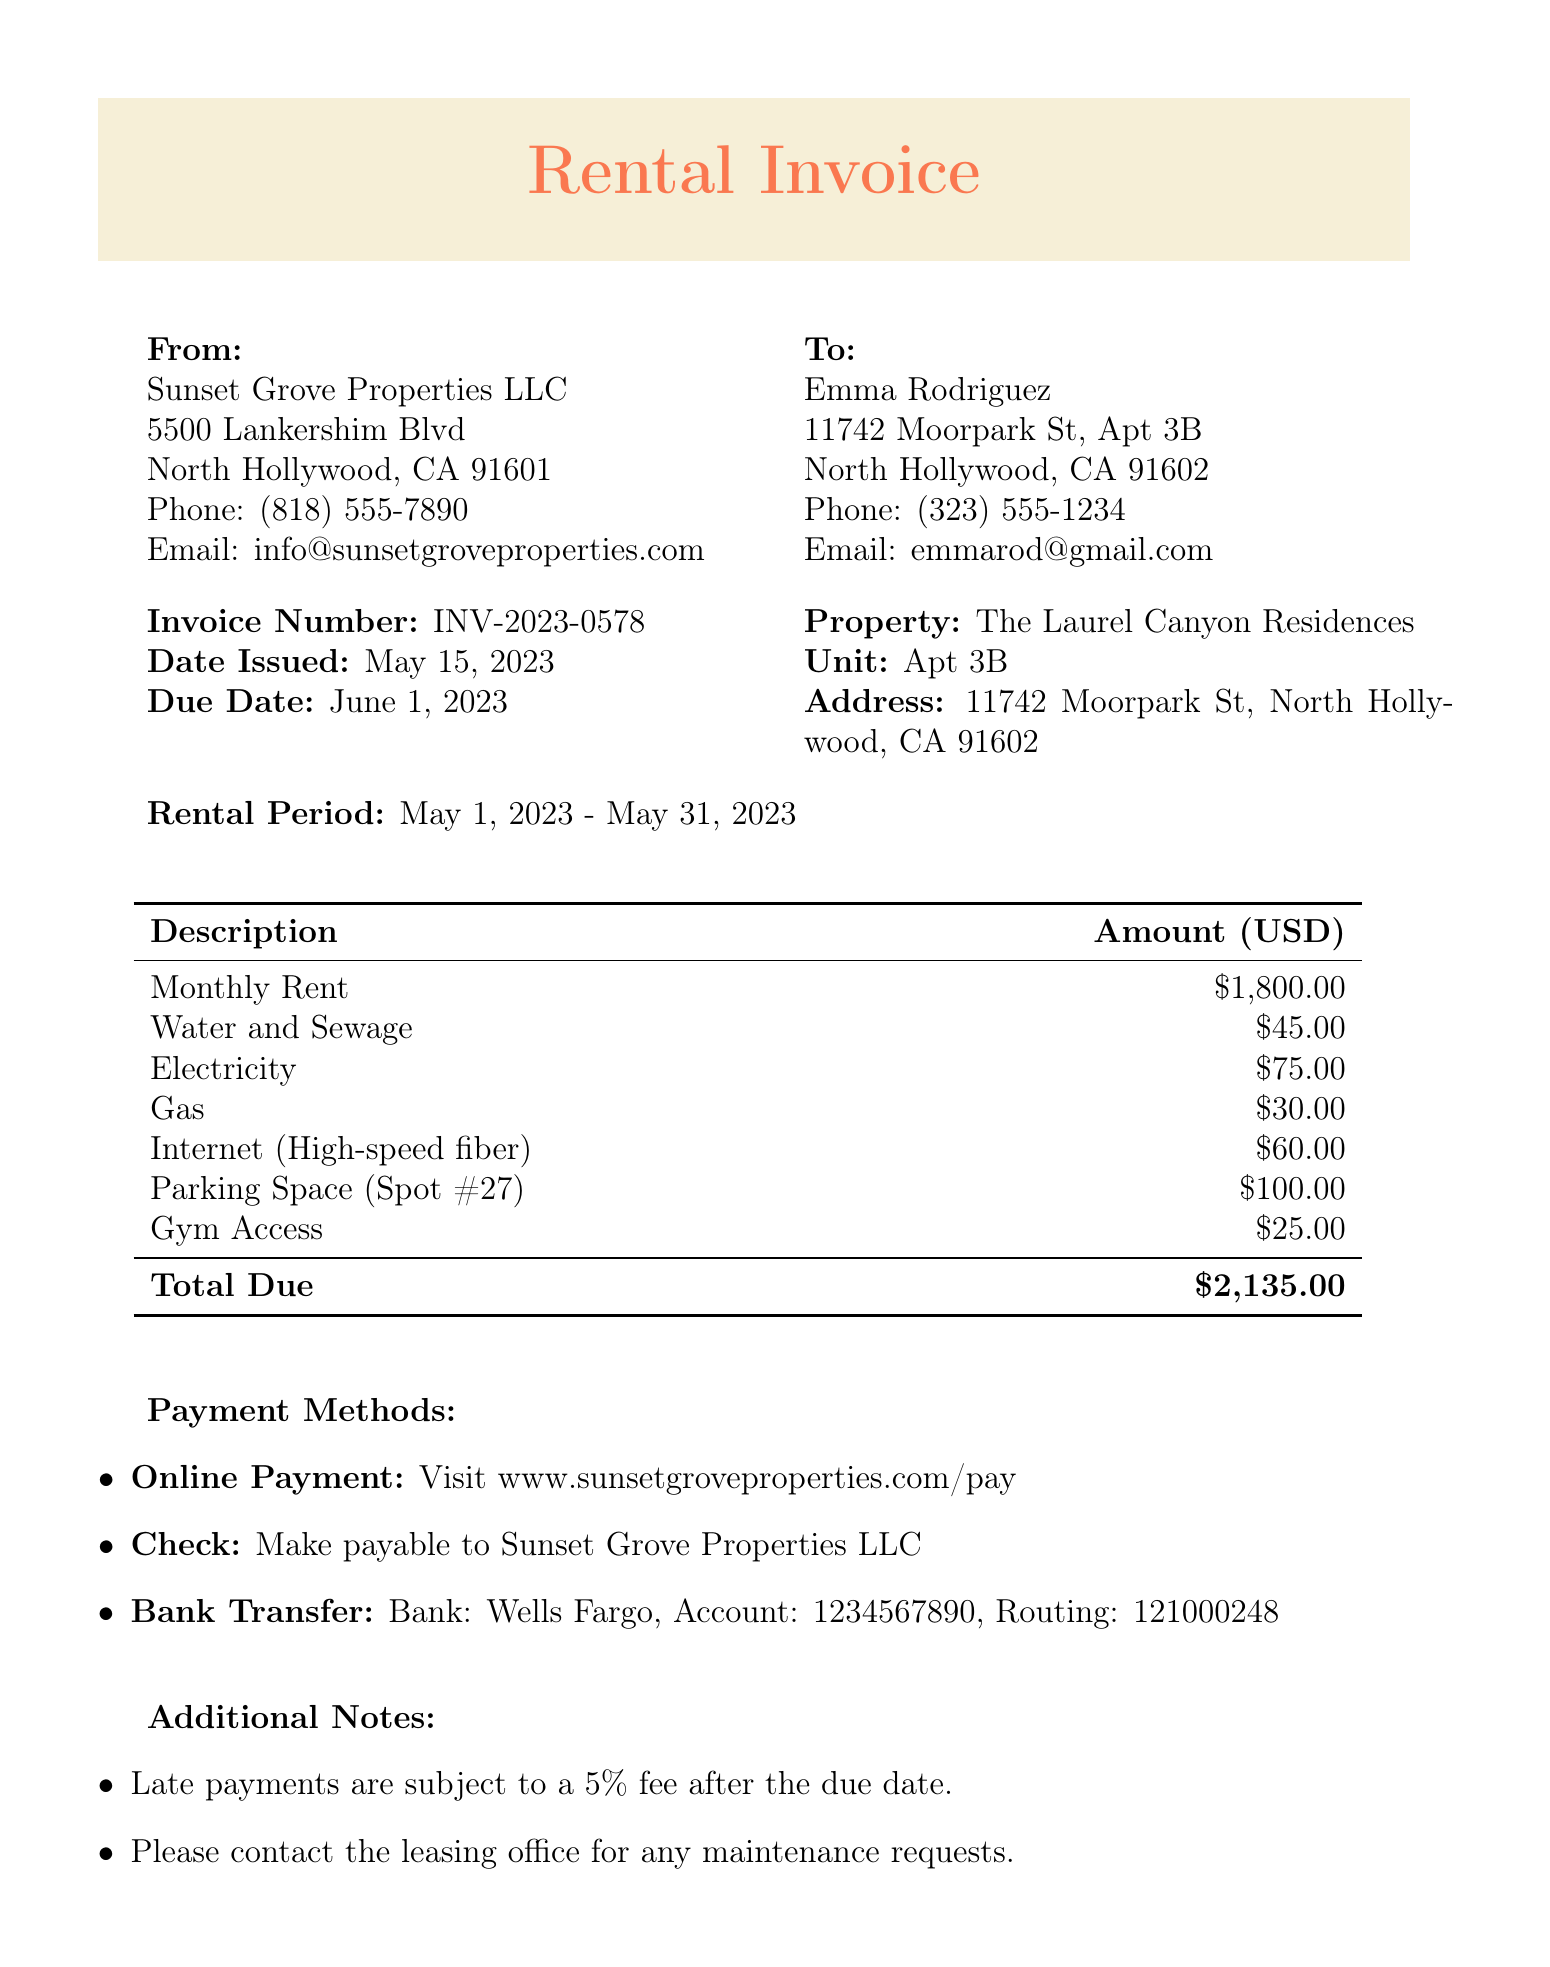What is the invoice number? The invoice number is specified in the document under the heading "Invoice Number."
Answer: INV-2023-0578 Who is the landlord? The landlord's name is provided at the beginning, which identifies the entity responsible for the property.
Answer: Sunset Grove Properties LLC What is the total due amount? The total due is listed in the charges section of the invoice, summarizing all costs incurred during the rental period.
Answer: $2,135.00 When is the due date for the invoice? The due date is clearly stated in the invoice under the "Due Date" heading.
Answer: June 1, 2023 What period does this rental invoice cover? The invoice specifies the rental period which details the dates covered for the rent charged.
Answer: May 1, 2023 - May 31, 2023 How much is the parking space fee? The fee for the parking space is broken out among the charges associated with the rental invoice.
Answer: $100.00 What payment methods are accepted? The document lists specific methods for payment, providing options available to the tenant.
Answer: Online Payment, Check, Bank Transfer What is the penalty for late payments? The invoice includes a note about the consequences for delayed payment, summarizing the applicable fees.
Answer: 5% fee after the due date Who should be contacted for maintenance requests? The document has additional notes that specify whom the tenant should reach out to regarding maintenance issues.
Answer: The leasing office 